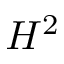<formula> <loc_0><loc_0><loc_500><loc_500>H ^ { 2 }</formula> 